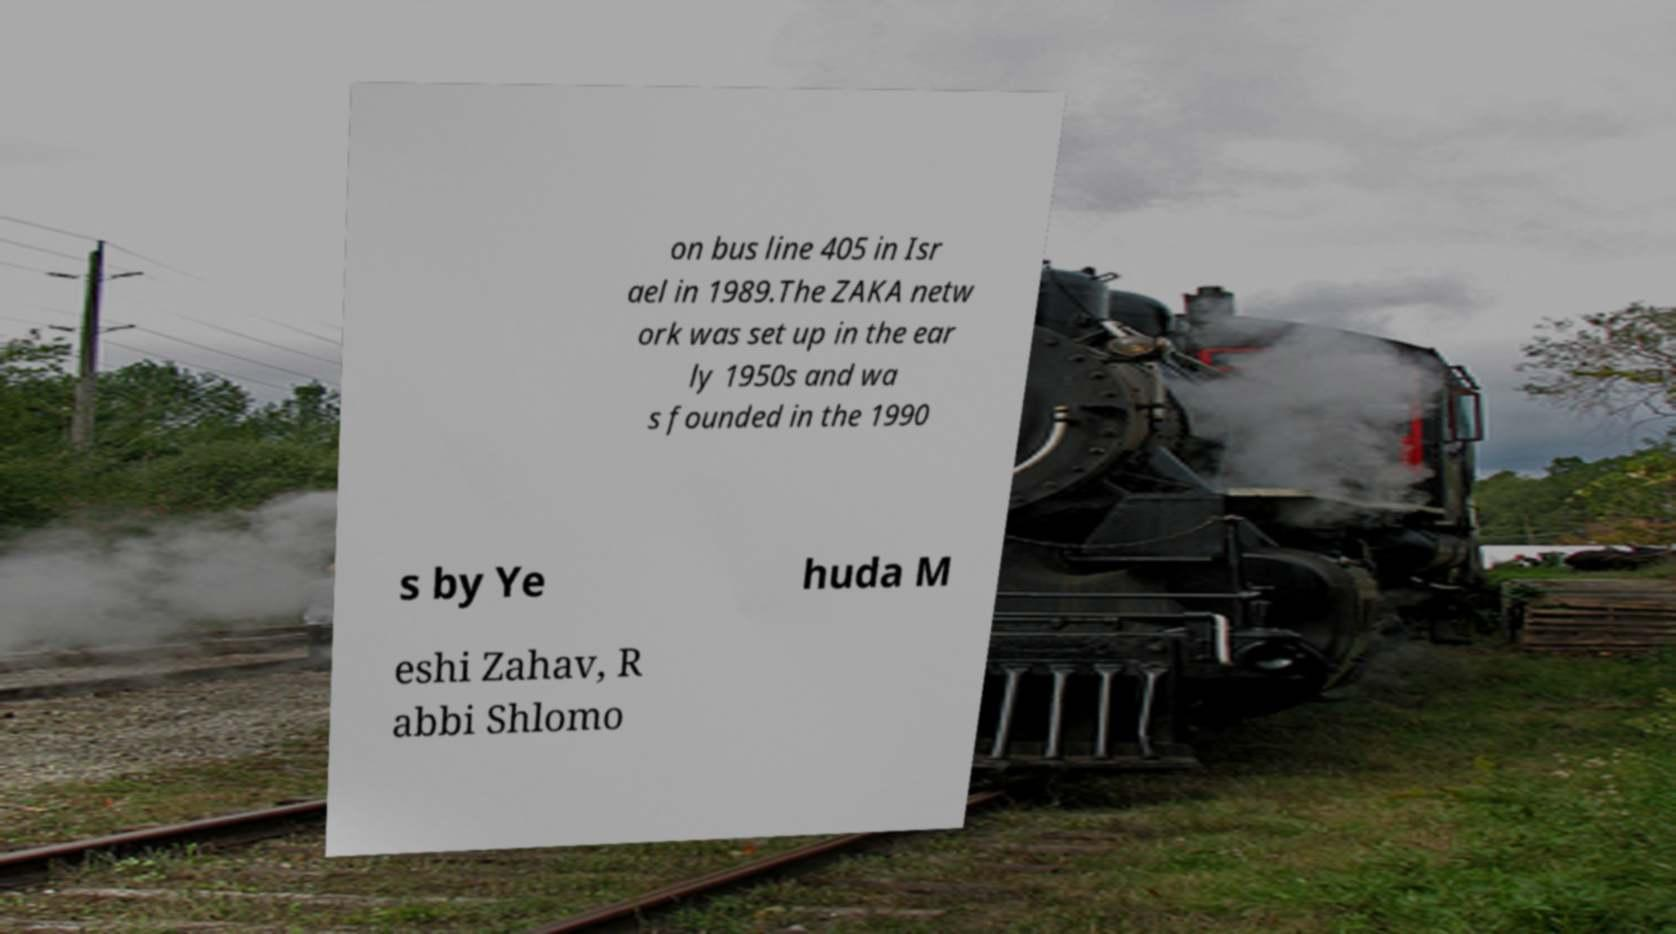There's text embedded in this image that I need extracted. Can you transcribe it verbatim? on bus line 405 in Isr ael in 1989.The ZAKA netw ork was set up in the ear ly 1950s and wa s founded in the 1990 s by Ye huda M eshi Zahav, R abbi Shlomo 